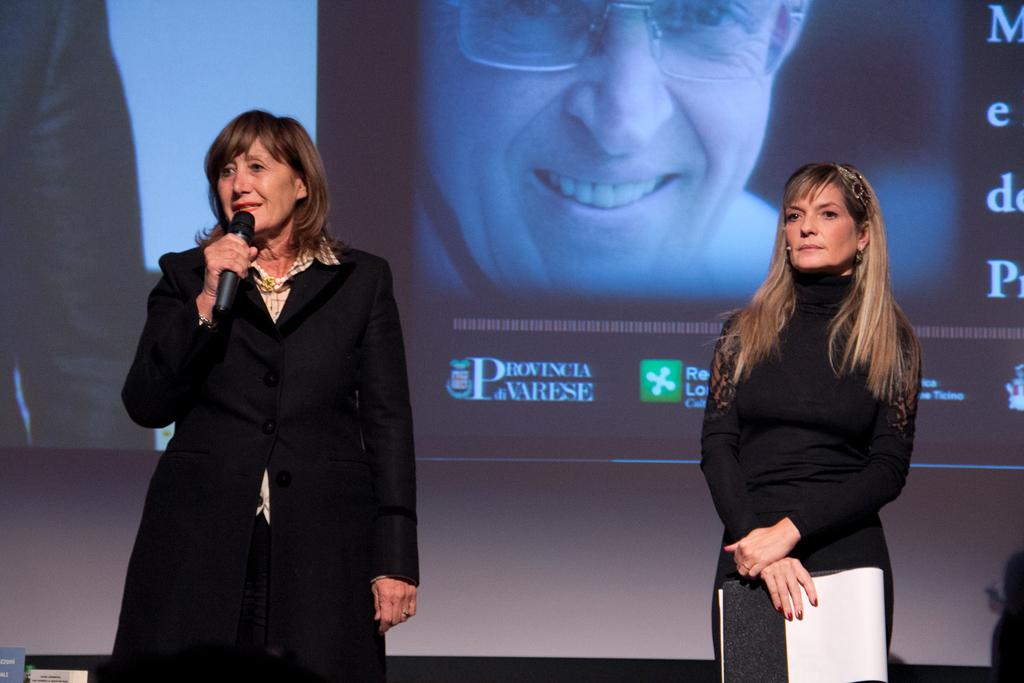How many women are in the image? There are two women in the image. What is the woman on the left side holding? The woman on the left side is holding a microphone. What is the woman on the right side holding? The woman on the right side is holding a book. What can be seen in the background of the image? There is a screen visible in the background of the image. What type of knife is the woman on the right side using to turn the wheel in the image? There is no knife or wheel present in the image. The woman on the right side is holding a book, not a knife. 